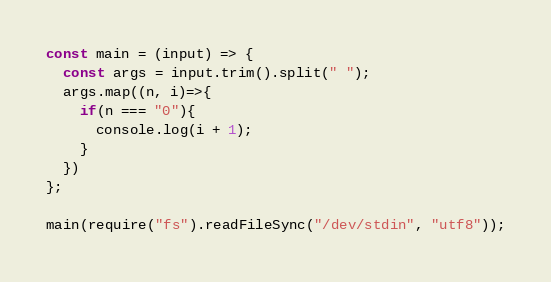Convert code to text. <code><loc_0><loc_0><loc_500><loc_500><_JavaScript_>const main = (input) => {
  const args = input.trim().split(" ");
  args.map((n, i)=>{
    if(n === "0"){
      console.log(i + 1);
    }
  })
};

main(require("fs").readFileSync("/dev/stdin", "utf8"));</code> 